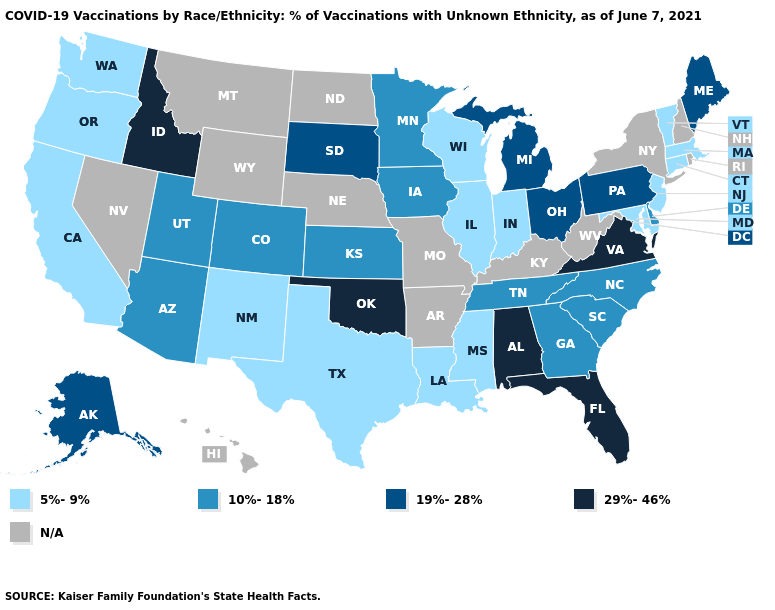Does the first symbol in the legend represent the smallest category?
Give a very brief answer. Yes. What is the lowest value in states that border South Carolina?
Keep it brief. 10%-18%. Name the states that have a value in the range N/A?
Concise answer only. Arkansas, Hawaii, Kentucky, Missouri, Montana, Nebraska, Nevada, New Hampshire, New York, North Dakota, Rhode Island, West Virginia, Wyoming. Does Idaho have the highest value in the USA?
Answer briefly. Yes. What is the value of Michigan?
Short answer required. 19%-28%. Which states have the highest value in the USA?
Be succinct. Alabama, Florida, Idaho, Oklahoma, Virginia. What is the value of Oklahoma?
Write a very short answer. 29%-46%. What is the lowest value in the MidWest?
Give a very brief answer. 5%-9%. What is the value of Arizona?
Write a very short answer. 10%-18%. What is the value of Kansas?
Be succinct. 10%-18%. What is the value of Kentucky?
Short answer required. N/A. Name the states that have a value in the range 10%-18%?
Answer briefly. Arizona, Colorado, Delaware, Georgia, Iowa, Kansas, Minnesota, North Carolina, South Carolina, Tennessee, Utah. Does Colorado have the lowest value in the USA?
Give a very brief answer. No. Which states have the highest value in the USA?
Keep it brief. Alabama, Florida, Idaho, Oklahoma, Virginia. 